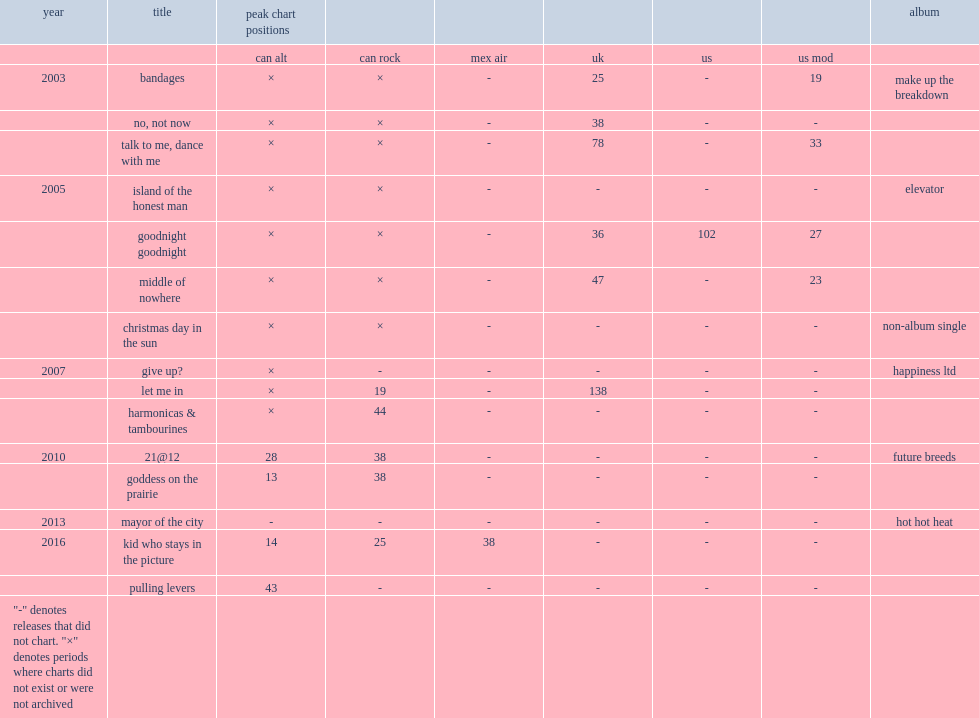Which song is debuted in 2013 by hot hot heat? Mayor of the city. 